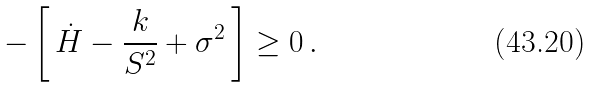Convert formula to latex. <formula><loc_0><loc_0><loc_500><loc_500>- \left [ \, \dot { H } - \frac { k } { S ^ { 2 } } + \sigma ^ { 2 } \, \right ] \geq 0 \, .</formula> 